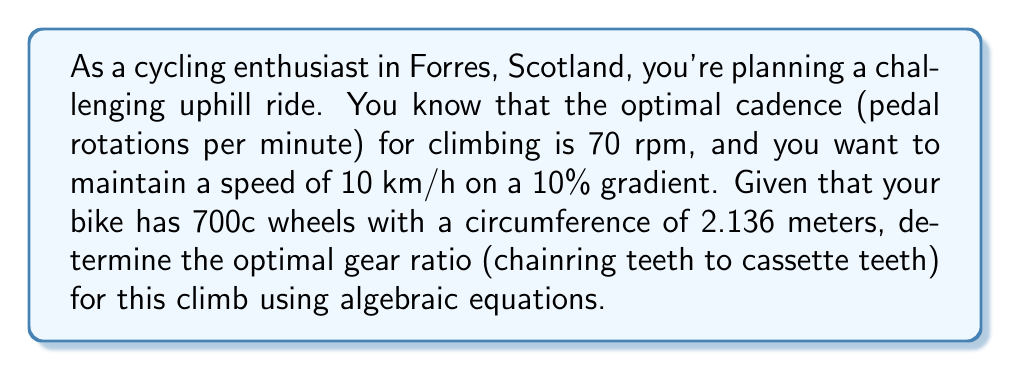Could you help me with this problem? Let's approach this step-by-step:

1) First, we need to convert the speed from km/h to m/min:
   $$ 10 \frac{km}{h} = 10 \times \frac{1000 m}{60 min} = 166.67 \frac{m}{min} $$

2) Now, let's define our variables:
   Let $x$ be the number of teeth on the chainring
   Let $y$ be the number of teeth on the cassette cog

3) The gear ratio is expressed as $\frac{x}{y}$

4) We know that for each pedal revolution, the wheel rotates $\frac{x}{y}$ times

5) The distance covered in one pedal revolution is:
   $$ d = 2.136 \times \frac{x}{y} \text{ meters} $$

6) Given the cadence of 70 rpm, the distance covered per minute is:
   $$ 70 \times 2.136 \times \frac{x}{y} = 166.67 $$

7) Solving this equation:
   $$ 149.52 \times \frac{x}{y} = 166.67 $$
   $$ \frac{x}{y} = \frac{166.67}{149.52} = 1.1146 $$

8) This ratio can be approximated by common gear combinations. A close match would be:
   $$ \frac{34}{30} = 1.1333 $$

Therefore, the optimal gear ratio is approximately 34:30.
Answer: 34:30 